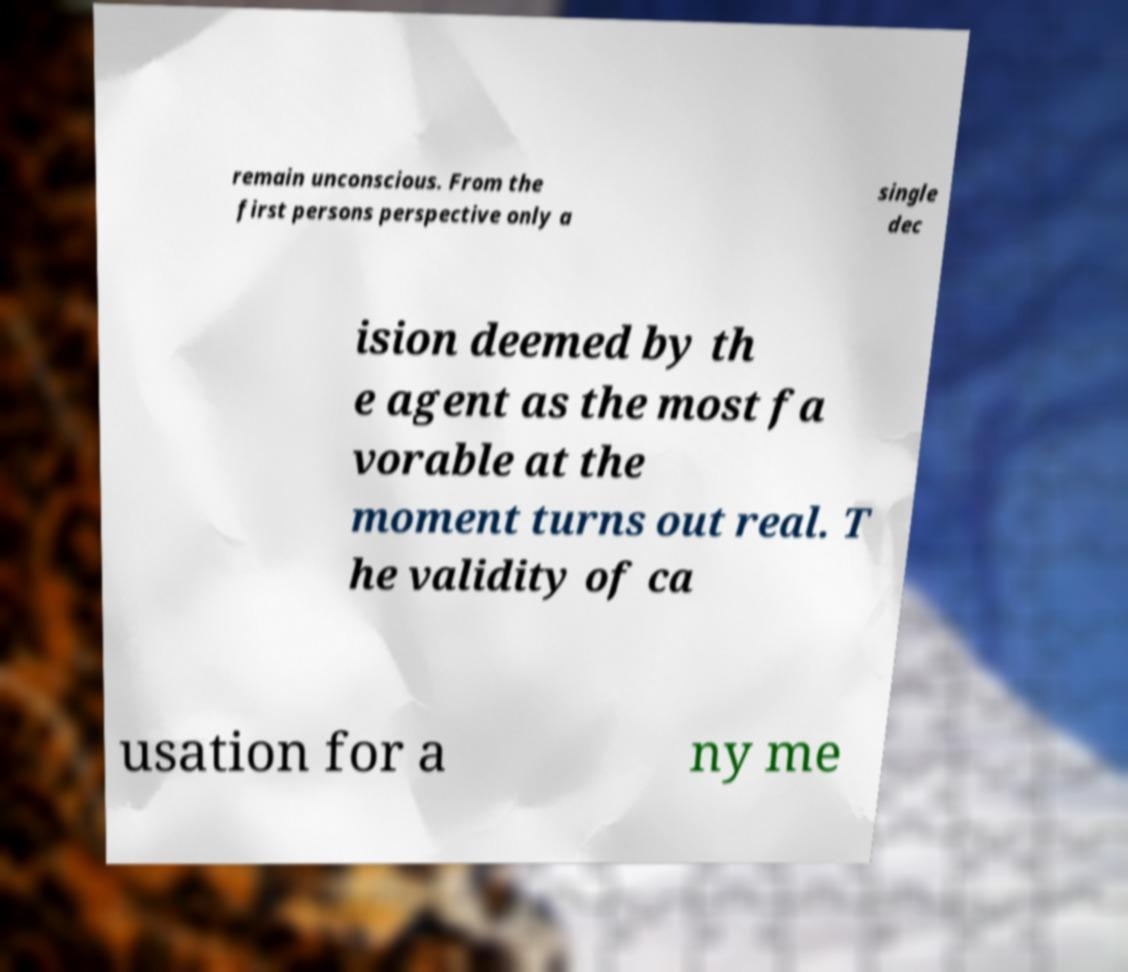Can you read and provide the text displayed in the image?This photo seems to have some interesting text. Can you extract and type it out for me? remain unconscious. From the first persons perspective only a single dec ision deemed by th e agent as the most fa vorable at the moment turns out real. T he validity of ca usation for a ny me 